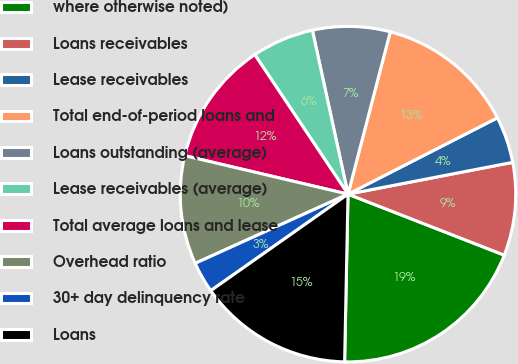Convert chart to OTSL. <chart><loc_0><loc_0><loc_500><loc_500><pie_chart><fcel>where otherwise noted)<fcel>Loans receivables<fcel>Lease receivables<fcel>Total end-of-period loans and<fcel>Loans outstanding (average)<fcel>Lease receivables (average)<fcel>Total average loans and lease<fcel>Overhead ratio<fcel>30+ day delinquency rate<fcel>Loans<nl><fcel>19.4%<fcel>8.96%<fcel>4.48%<fcel>13.43%<fcel>7.46%<fcel>5.97%<fcel>11.94%<fcel>10.45%<fcel>2.99%<fcel>14.92%<nl></chart> 